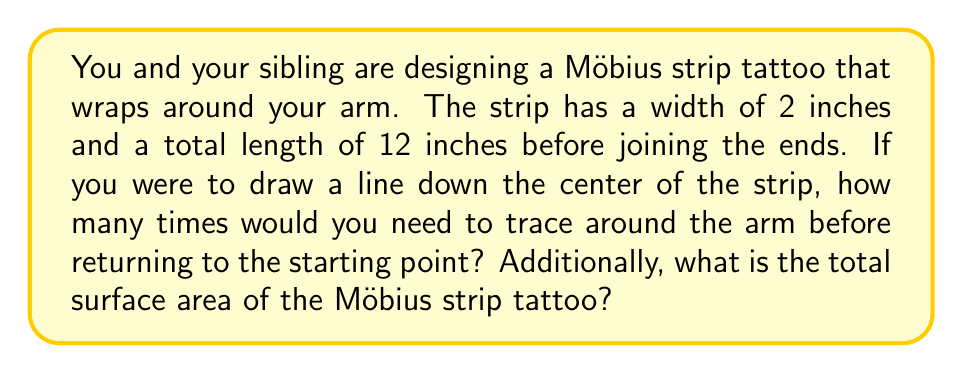Could you help me with this problem? Let's approach this problem step-by-step:

1. Properties of a Möbius strip:
   - A Möbius strip has only one side and one edge.
   - It is non-orientable, meaning if you follow a path along the surface, you'll return to the starting point but flipped.

2. Tracing the center line:
   - In a regular cylinder, you would return to the starting point after one revolution.
   - In a Möbius strip, you need to go around twice to return to the starting point.
   - This is because after one revolution, you're on the "other side" of the strip.

3. Surface area calculation:
   - The formula for the surface area of a Möbius strip is:
     $$ A = \frac{1}{2} \cdot l \cdot w $$
   where $A$ is the area, $l$ is the length, and $w$ is the width.

   - In this case:
     $l = 12$ inches
     $w = 2$ inches

   - Plugging these values into the formula:
     $$ A = \frac{1}{2} \cdot 12 \cdot 2 = 12 \text{ square inches} $$

4. Why is it half the area of a regular strip?
   - A regular strip would have an area of $l \cdot w = 12 \cdot 2 = 24$ square inches.
   - The Möbius strip has half this area because it effectively has only one side.

[asy]
import geometry;

path p = (0,0)--(12,0)--(12,2)--(0,2)--cycle;
fill(p,lightgrey);
draw(p);
draw((0,1)--(12,1),dashed);
label("12 inches",(-1,1),W);
label("2 inches",(6,2.5),N);

path arrow = (3,2.5)..(6,3)..(9,2.5);
draw(arrow,Arrow);
label("Twist and join ends",(6,3.5),N);
[/asy]
Answer: You would need to trace around the arm twice to return to the starting point. The total surface area of the Möbius strip tattoo is 12 square inches. 